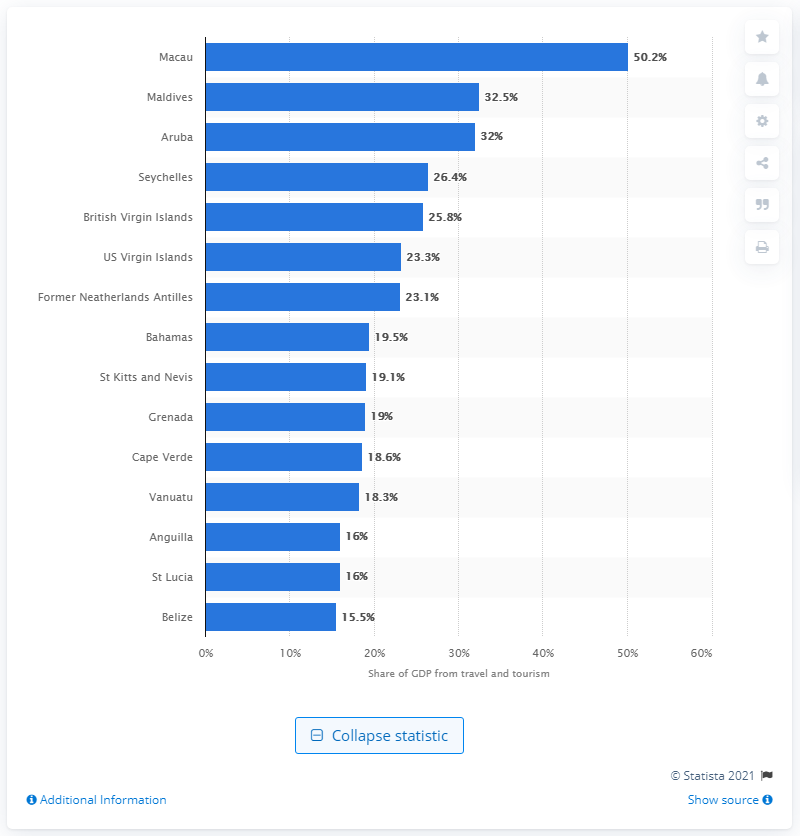Indicate a few pertinent items in this graphic. According to the data, the Maldives had the second highest share of its Gross Domestic Product (GDP) generated by direct travel and tourism in 2019, representing a significant contribution to its economy. 